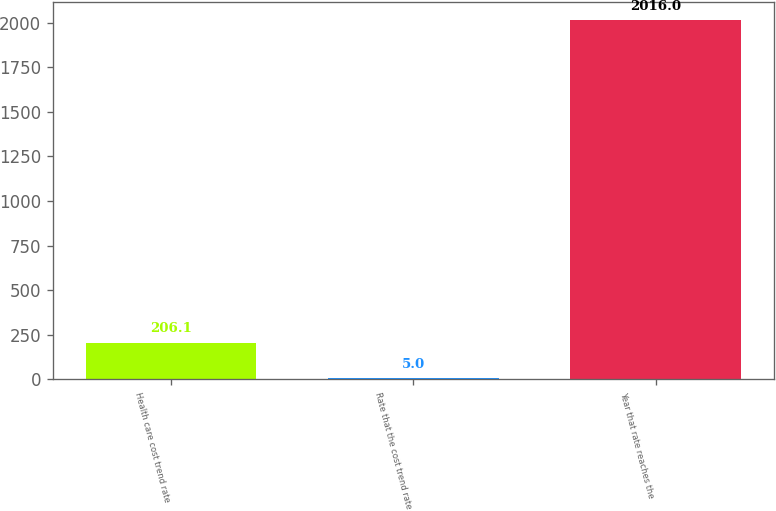<chart> <loc_0><loc_0><loc_500><loc_500><bar_chart><fcel>Health care cost trend rate<fcel>Rate that the cost trend rate<fcel>Year that rate reaches the<nl><fcel>206.1<fcel>5<fcel>2016<nl></chart> 